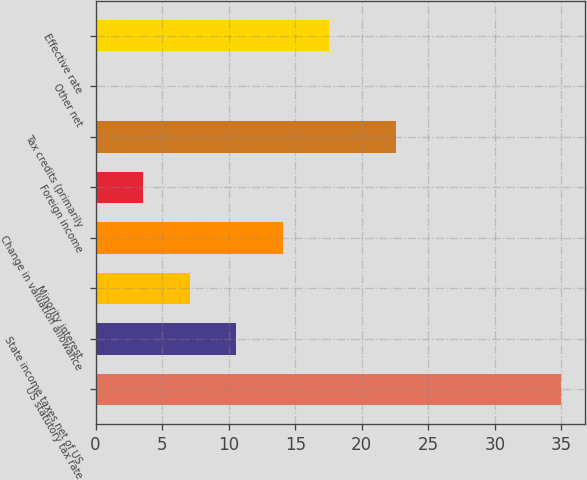<chart> <loc_0><loc_0><loc_500><loc_500><bar_chart><fcel>US statutory tax rate<fcel>State income taxes net of US<fcel>Minority interest<fcel>Change in valuation allowance<fcel>Foreign income<fcel>Tax credits (primarily<fcel>Other net<fcel>Effective rate<nl><fcel>35<fcel>10.57<fcel>7.08<fcel>14.06<fcel>3.59<fcel>22.6<fcel>0.1<fcel>17.55<nl></chart> 